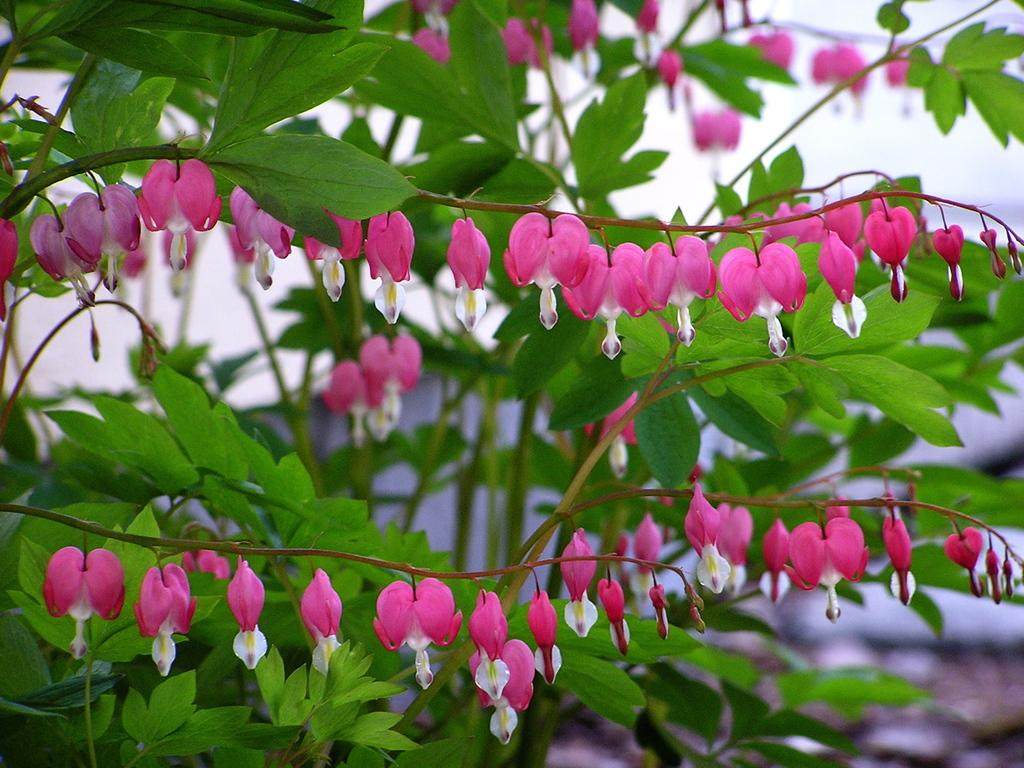What is the main subject of the image? The main subject of the image is a bunch of flowers. What are the flowers attached to? The flowers have stems. What else is visible on the flowers besides the petals? The flowers have leaves. What color is the background of the image? The background of the image is white. How many beggars are visible in the image? There are no beggars present in the image; it features a bunch of flowers. What color are the brothers' shirts in the image? There are no brothers or shirts present in the image. 